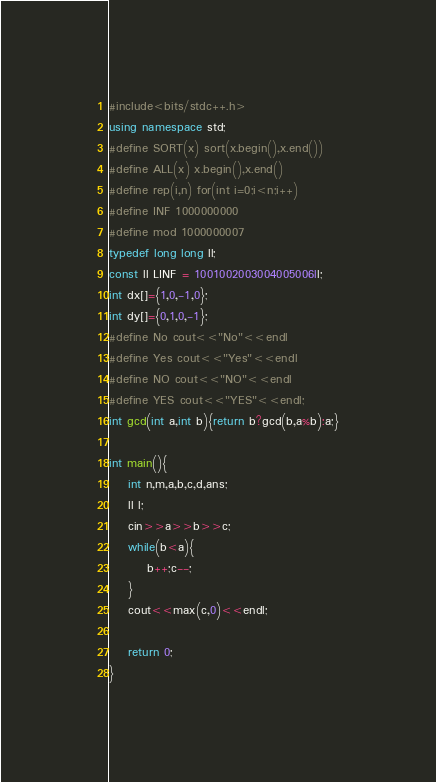<code> <loc_0><loc_0><loc_500><loc_500><_C++_>#include<bits/stdc++.h>
using namespace std;
#define SORT(x) sort(x.begin(),x.end())
#define ALL(x) x.begin(),x.end()
#define rep(i,n) for(int i=0;i<n;i++)
#define INF 1000000000
#define mod 1000000007
typedef long long ll;
const ll LINF = 1001002003004005006ll;
int dx[]={1,0,-1,0};
int dy[]={0,1,0,-1};
#define No cout<<"No"<<endl
#define Yes cout<<"Yes"<<endl
#define NO cout<<"NO"<<endl
#define YES cout<<"YES"<<endl;
int gcd(int a,int b){return b?gcd(b,a%b):a;}

int main(){
    int n,m,a,b,c,d,ans;
    ll l;
    cin>>a>>b>>c;
    while(b<a){
        b++;c--;
    }
    cout<<max(c,0)<<endl;
    
    return 0;
}
</code> 